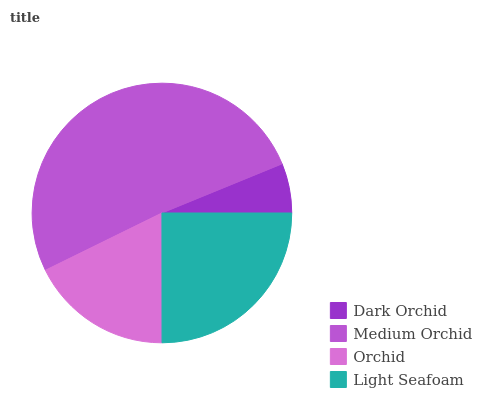Is Dark Orchid the minimum?
Answer yes or no. Yes. Is Medium Orchid the maximum?
Answer yes or no. Yes. Is Orchid the minimum?
Answer yes or no. No. Is Orchid the maximum?
Answer yes or no. No. Is Medium Orchid greater than Orchid?
Answer yes or no. Yes. Is Orchid less than Medium Orchid?
Answer yes or no. Yes. Is Orchid greater than Medium Orchid?
Answer yes or no. No. Is Medium Orchid less than Orchid?
Answer yes or no. No. Is Light Seafoam the high median?
Answer yes or no. Yes. Is Orchid the low median?
Answer yes or no. Yes. Is Dark Orchid the high median?
Answer yes or no. No. Is Dark Orchid the low median?
Answer yes or no. No. 